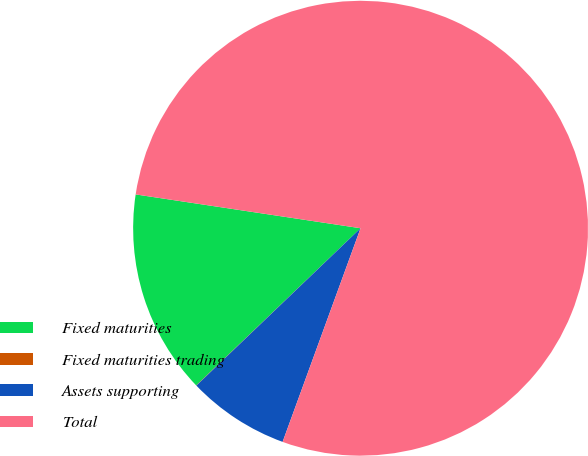<chart> <loc_0><loc_0><loc_500><loc_500><pie_chart><fcel>Fixed maturities<fcel>Fixed maturities trading<fcel>Assets supporting<fcel>Total<nl><fcel>14.52%<fcel>0.02%<fcel>7.27%<fcel>78.2%<nl></chart> 